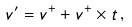<formula> <loc_0><loc_0><loc_500><loc_500>v ^ { \prime } = v ^ { + } + v ^ { + } \times t \, ,</formula> 